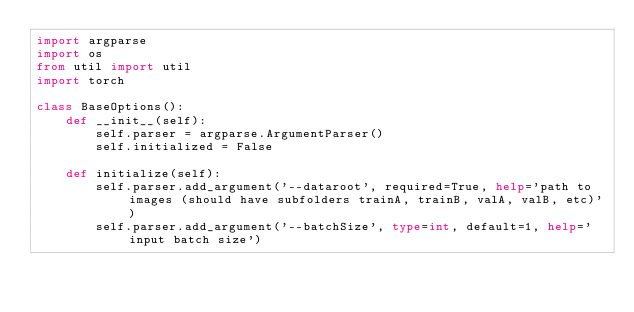Convert code to text. <code><loc_0><loc_0><loc_500><loc_500><_Python_>import argparse
import os
from util import util
import torch

class BaseOptions():
	def __init__(self):
		self.parser = argparse.ArgumentParser()
		self.initialized = False

	def initialize(self):
		self.parser.add_argument('--dataroot', required=True, help='path to images (should have subfolders trainA, trainB, valA, valB, etc)')
		self.parser.add_argument('--batchSize', type=int, default=1, help='input batch size')</code> 